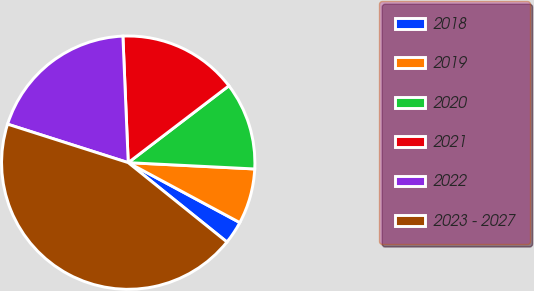<chart> <loc_0><loc_0><loc_500><loc_500><pie_chart><fcel>2018<fcel>2019<fcel>2020<fcel>2021<fcel>2022<fcel>2023 - 2027<nl><fcel>2.93%<fcel>7.05%<fcel>11.17%<fcel>15.29%<fcel>19.41%<fcel>44.13%<nl></chart> 